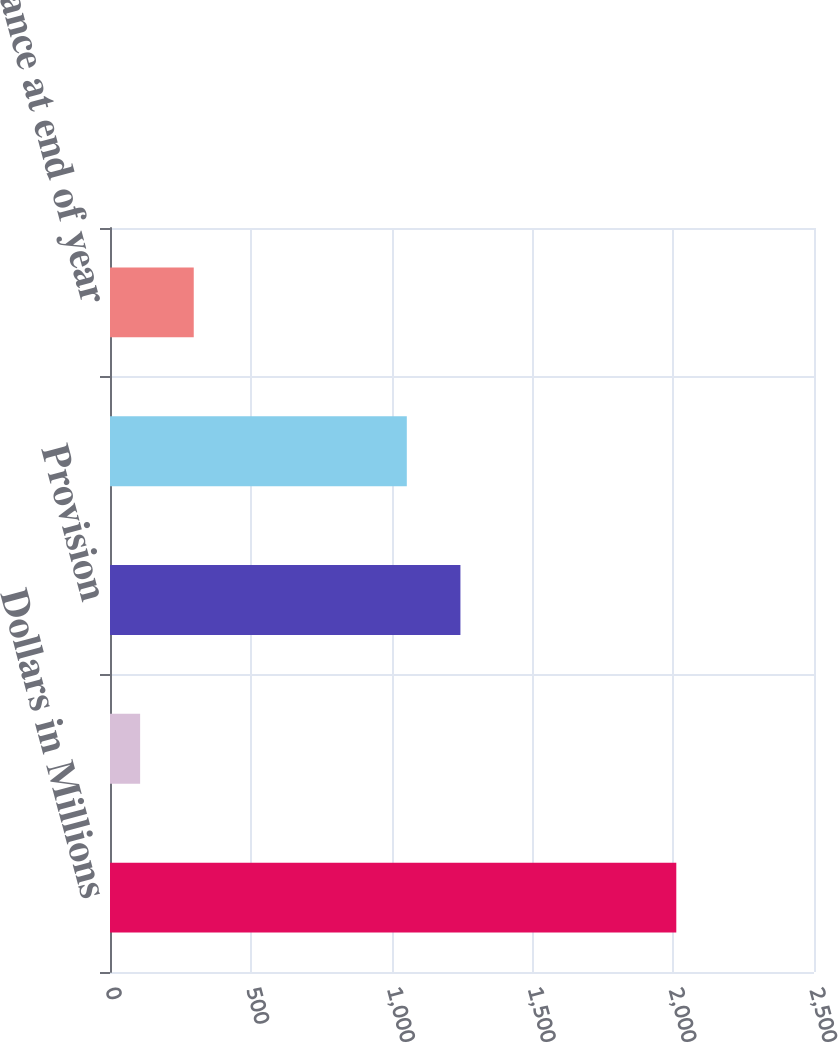<chart> <loc_0><loc_0><loc_500><loc_500><bar_chart><fcel>Dollars in Millions<fcel>Balance at beginning of year<fcel>Provision<fcel>Utilization<fcel>Balance at end of year<nl><fcel>2011<fcel>107<fcel>1244.4<fcel>1054<fcel>297.4<nl></chart> 